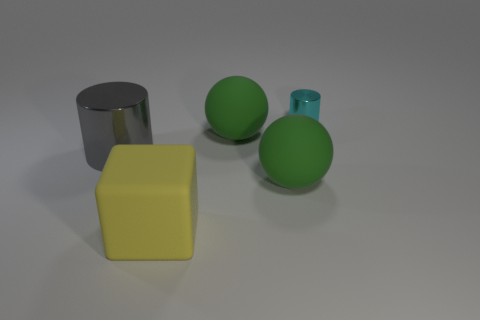Is the number of gray shiny things greater than the number of big yellow shiny cylinders?
Offer a very short reply. Yes. Does the shiny cylinder that is left of the big cube have the same size as the metal cylinder that is on the right side of the gray metal cylinder?
Offer a terse response. No. There is a thing that is in front of the large green rubber ball that is in front of the shiny object that is in front of the small object; what is its color?
Offer a terse response. Yellow. Are there any other large things of the same shape as the cyan metallic object?
Make the answer very short. Yes. Are there more objects that are left of the block than large cyan matte objects?
Offer a very short reply. Yes. What number of matte objects are either gray cylinders or cyan cylinders?
Your answer should be very brief. 0. There is a matte thing that is both in front of the gray shiny object and behind the big rubber block; what is its size?
Make the answer very short. Large. Is there a large gray metallic object in front of the green thing that is behind the large metal thing?
Ensure brevity in your answer.  Yes. What number of big objects are in front of the small cyan shiny cylinder?
Your response must be concise. 4. What color is the other metallic thing that is the same shape as the big metallic object?
Offer a very short reply. Cyan. 